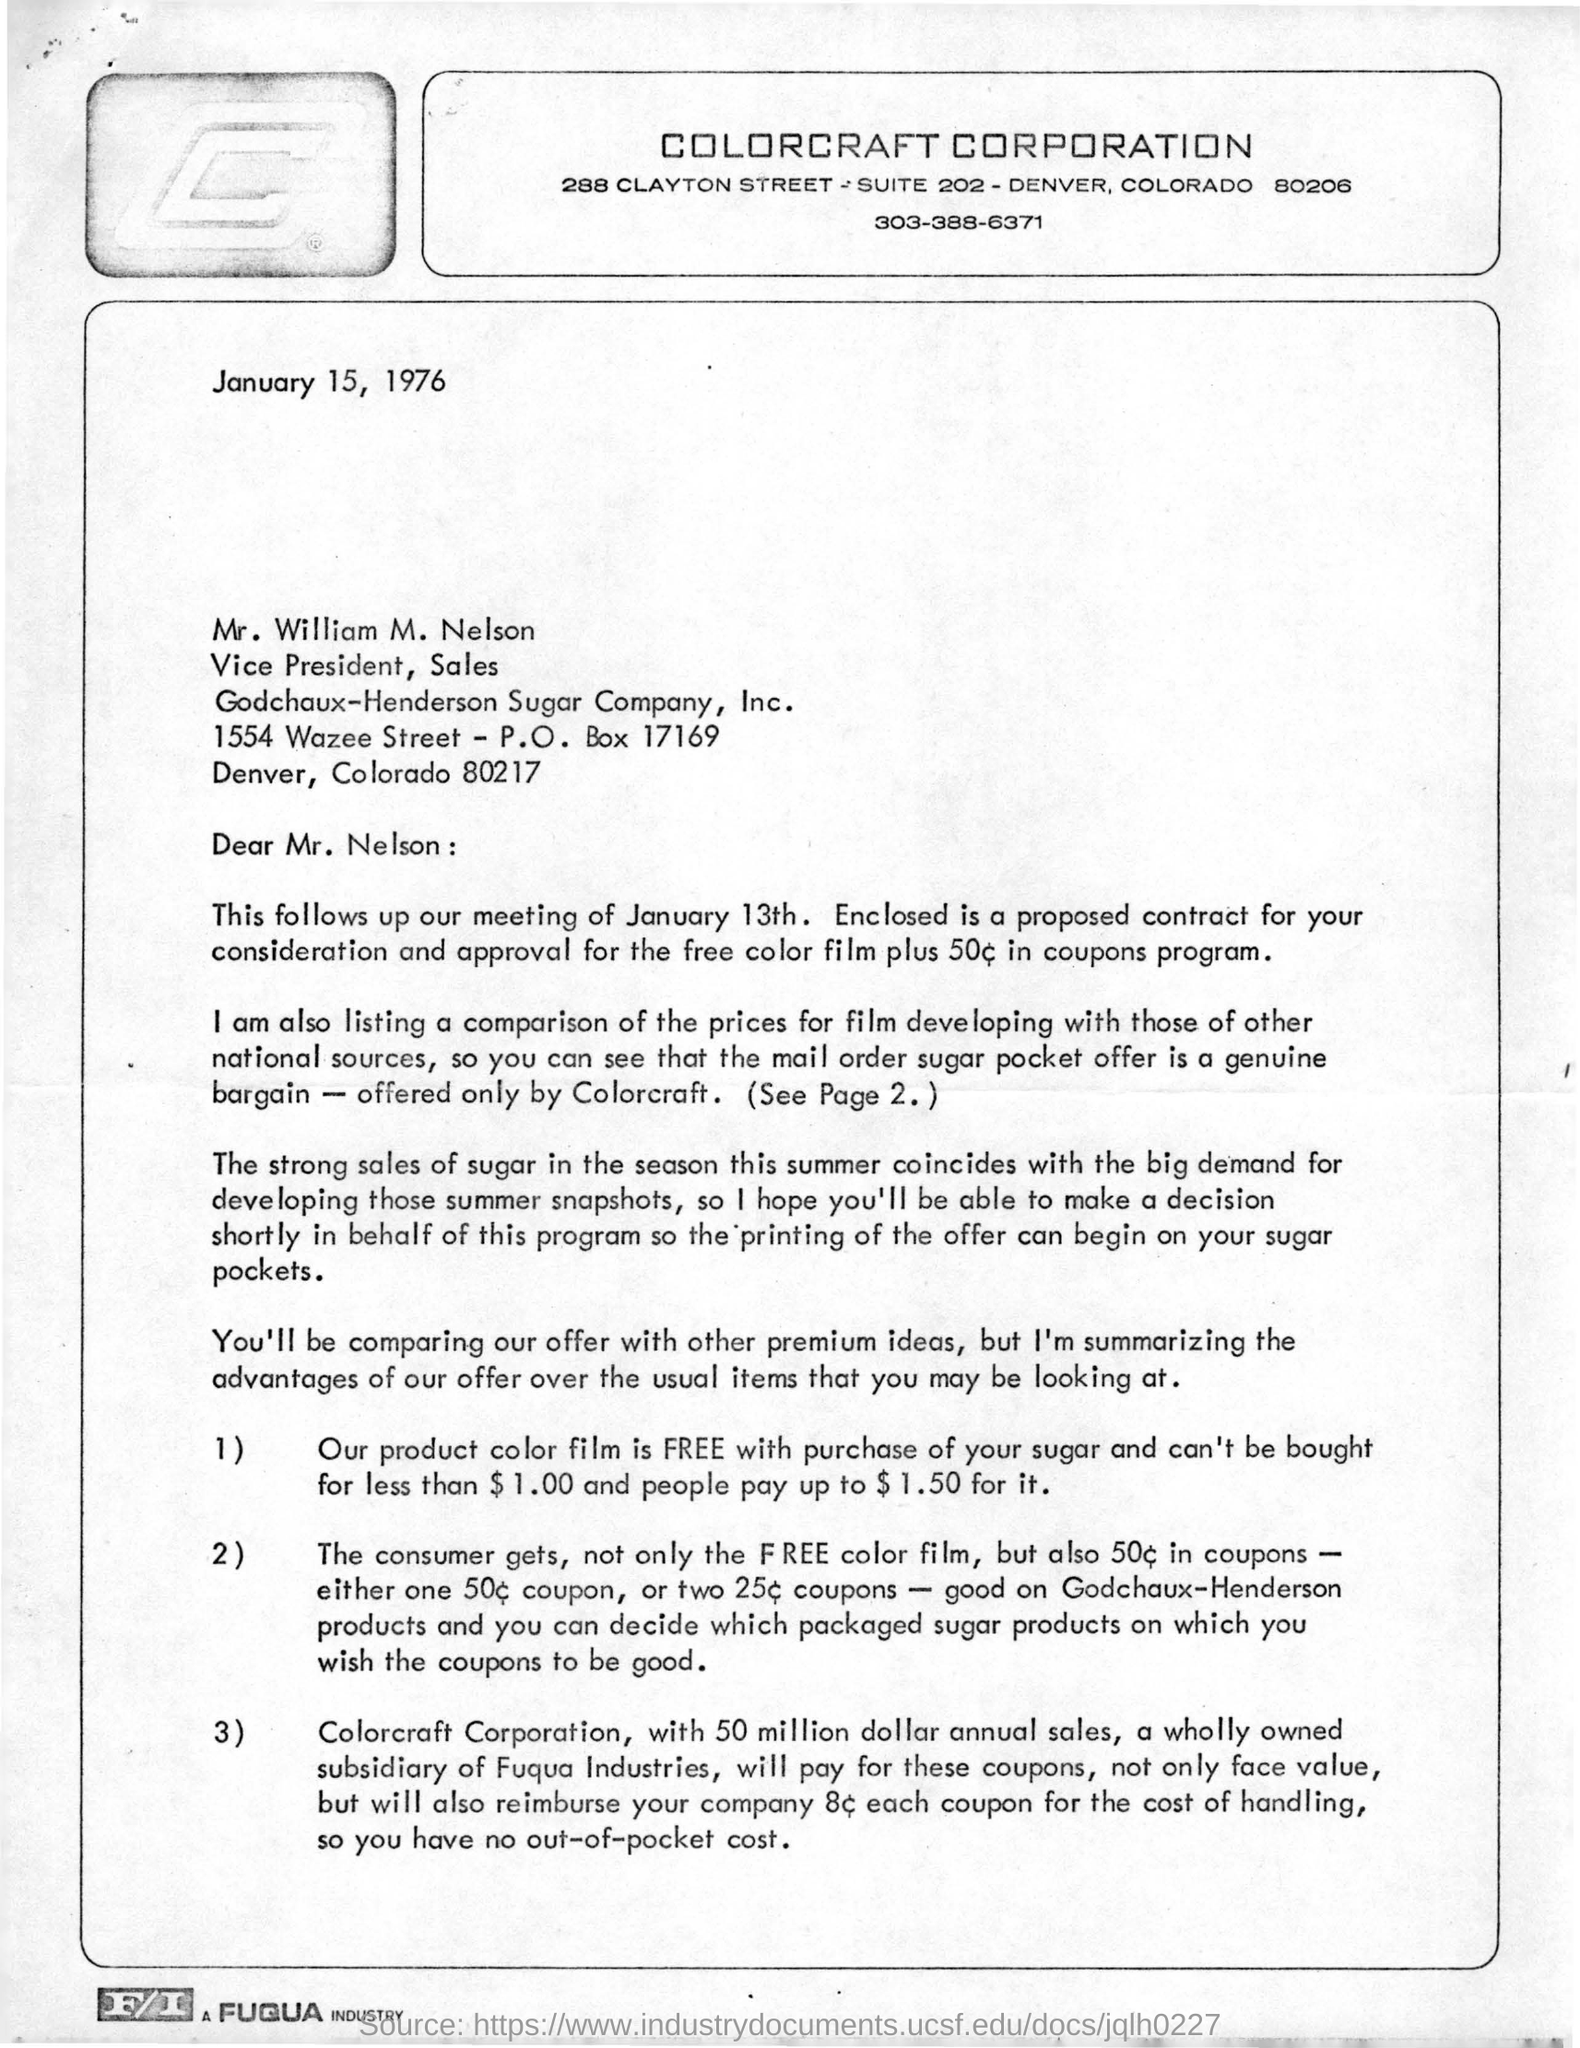Give some essential details in this illustration. This letter is addressed to William M. Nelson. The date of this letter is January 15, 1976. The letterhead in question belongs to Colorcraft Corporation. The sender is inquiring about the recipient's postal box number, which is 17169. The annual sales of Colorcraft Corporation are approximately 50 million dollars. 